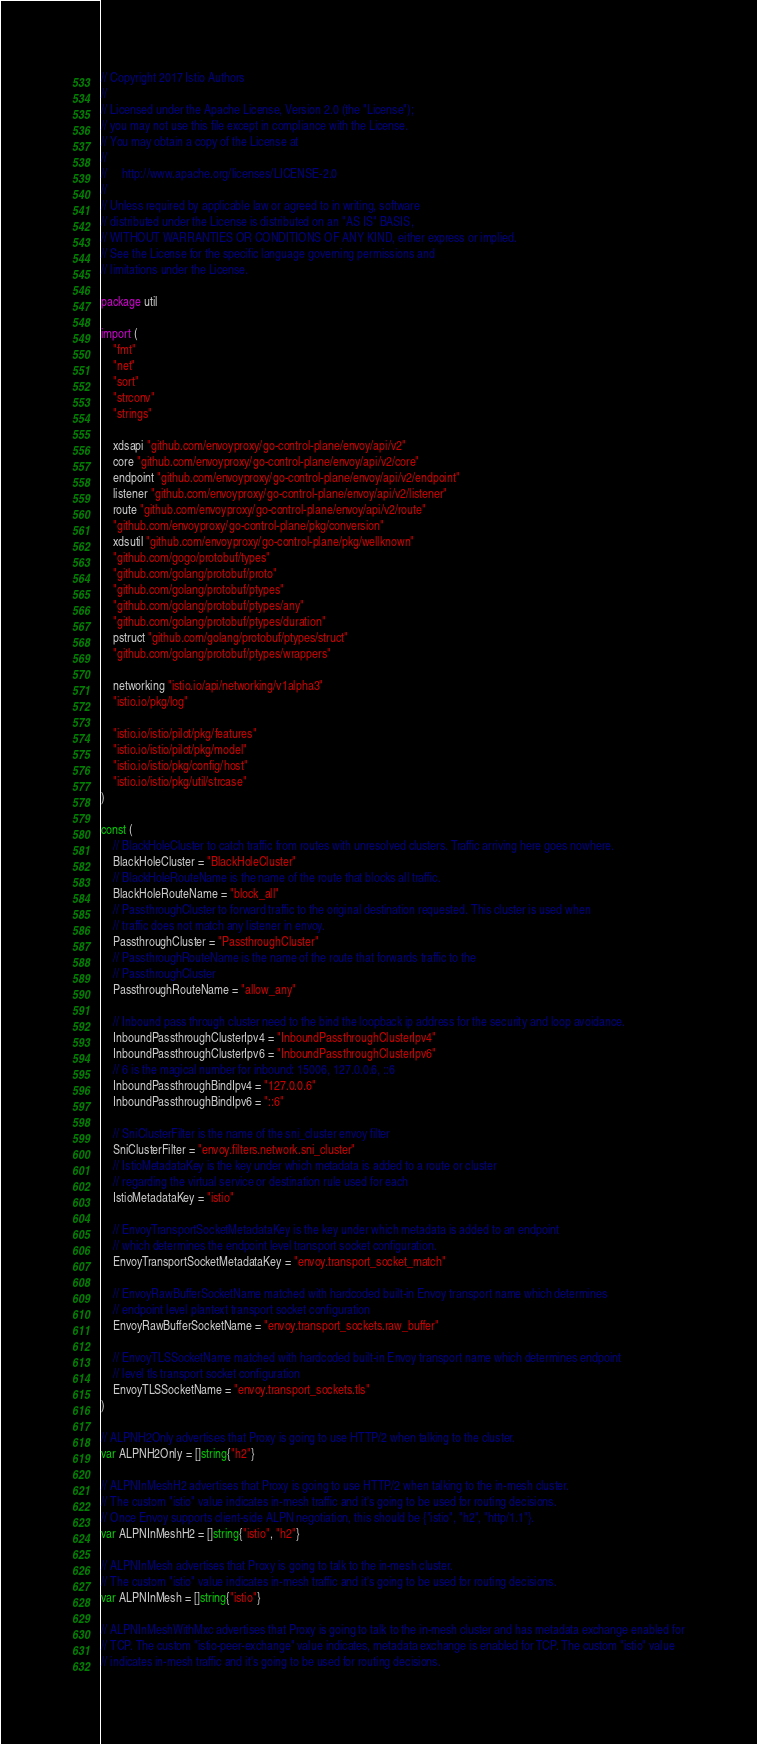Convert code to text. <code><loc_0><loc_0><loc_500><loc_500><_Go_>// Copyright 2017 Istio Authors
//
// Licensed under the Apache License, Version 2.0 (the "License");
// you may not use this file except in compliance with the License.
// You may obtain a copy of the License at
//
//     http://www.apache.org/licenses/LICENSE-2.0
//
// Unless required by applicable law or agreed to in writing, software
// distributed under the License is distributed on an "AS IS" BASIS,
// WITHOUT WARRANTIES OR CONDITIONS OF ANY KIND, either express or implied.
// See the License for the specific language governing permissions and
// limitations under the License.

package util

import (
	"fmt"
	"net"
	"sort"
	"strconv"
	"strings"

	xdsapi "github.com/envoyproxy/go-control-plane/envoy/api/v2"
	core "github.com/envoyproxy/go-control-plane/envoy/api/v2/core"
	endpoint "github.com/envoyproxy/go-control-plane/envoy/api/v2/endpoint"
	listener "github.com/envoyproxy/go-control-plane/envoy/api/v2/listener"
	route "github.com/envoyproxy/go-control-plane/envoy/api/v2/route"
	"github.com/envoyproxy/go-control-plane/pkg/conversion"
	xdsutil "github.com/envoyproxy/go-control-plane/pkg/wellknown"
	"github.com/gogo/protobuf/types"
	"github.com/golang/protobuf/proto"
	"github.com/golang/protobuf/ptypes"
	"github.com/golang/protobuf/ptypes/any"
	"github.com/golang/protobuf/ptypes/duration"
	pstruct "github.com/golang/protobuf/ptypes/struct"
	"github.com/golang/protobuf/ptypes/wrappers"

	networking "istio.io/api/networking/v1alpha3"
	"istio.io/pkg/log"

	"istio.io/istio/pilot/pkg/features"
	"istio.io/istio/pilot/pkg/model"
	"istio.io/istio/pkg/config/host"
	"istio.io/istio/pkg/util/strcase"
)

const (
	// BlackHoleCluster to catch traffic from routes with unresolved clusters. Traffic arriving here goes nowhere.
	BlackHoleCluster = "BlackHoleCluster"
	// BlackHoleRouteName is the name of the route that blocks all traffic.
	BlackHoleRouteName = "block_all"
	// PassthroughCluster to forward traffic to the original destination requested. This cluster is used when
	// traffic does not match any listener in envoy.
	PassthroughCluster = "PassthroughCluster"
	// PassthroughRouteName is the name of the route that forwards traffic to the
	// PassthroughCluster
	PassthroughRouteName = "allow_any"

	// Inbound pass through cluster need to the bind the loopback ip address for the security and loop avoidance.
	InboundPassthroughClusterIpv4 = "InboundPassthroughClusterIpv4"
	InboundPassthroughClusterIpv6 = "InboundPassthroughClusterIpv6"
	// 6 is the magical number for inbound: 15006, 127.0.0.6, ::6
	InboundPassthroughBindIpv4 = "127.0.0.6"
	InboundPassthroughBindIpv6 = "::6"

	// SniClusterFilter is the name of the sni_cluster envoy filter
	SniClusterFilter = "envoy.filters.network.sni_cluster"
	// IstioMetadataKey is the key under which metadata is added to a route or cluster
	// regarding the virtual service or destination rule used for each
	IstioMetadataKey = "istio"

	// EnvoyTransportSocketMetadataKey is the key under which metadata is added to an endpoint
	// which determines the endpoint level transport socket configuration.
	EnvoyTransportSocketMetadataKey = "envoy.transport_socket_match"

	// EnvoyRawBufferSocketName matched with hardcoded built-in Envoy transport name which determines
	// endpoint level plantext transport socket configuration
	EnvoyRawBufferSocketName = "envoy.transport_sockets.raw_buffer"

	// EnvoyTLSSocketName matched with hardcoded built-in Envoy transport name which determines endpoint
	// level tls transport socket configuration
	EnvoyTLSSocketName = "envoy.transport_sockets.tls"
)

// ALPNH2Only advertises that Proxy is going to use HTTP/2 when talking to the cluster.
var ALPNH2Only = []string{"h2"}

// ALPNInMeshH2 advertises that Proxy is going to use HTTP/2 when talking to the in-mesh cluster.
// The custom "istio" value indicates in-mesh traffic and it's going to be used for routing decisions.
// Once Envoy supports client-side ALPN negotiation, this should be {"istio", "h2", "http/1.1"}.
var ALPNInMeshH2 = []string{"istio", "h2"}

// ALPNInMesh advertises that Proxy is going to talk to the in-mesh cluster.
// The custom "istio" value indicates in-mesh traffic and it's going to be used for routing decisions.
var ALPNInMesh = []string{"istio"}

// ALPNInMeshWithMxc advertises that Proxy is going to talk to the in-mesh cluster and has metadata exchange enabled for
// TCP. The custom "istio-peer-exchange" value indicates, metadata exchange is enabled for TCP. The custom "istio" value
// indicates in-mesh traffic and it's going to be used for routing decisions.</code> 